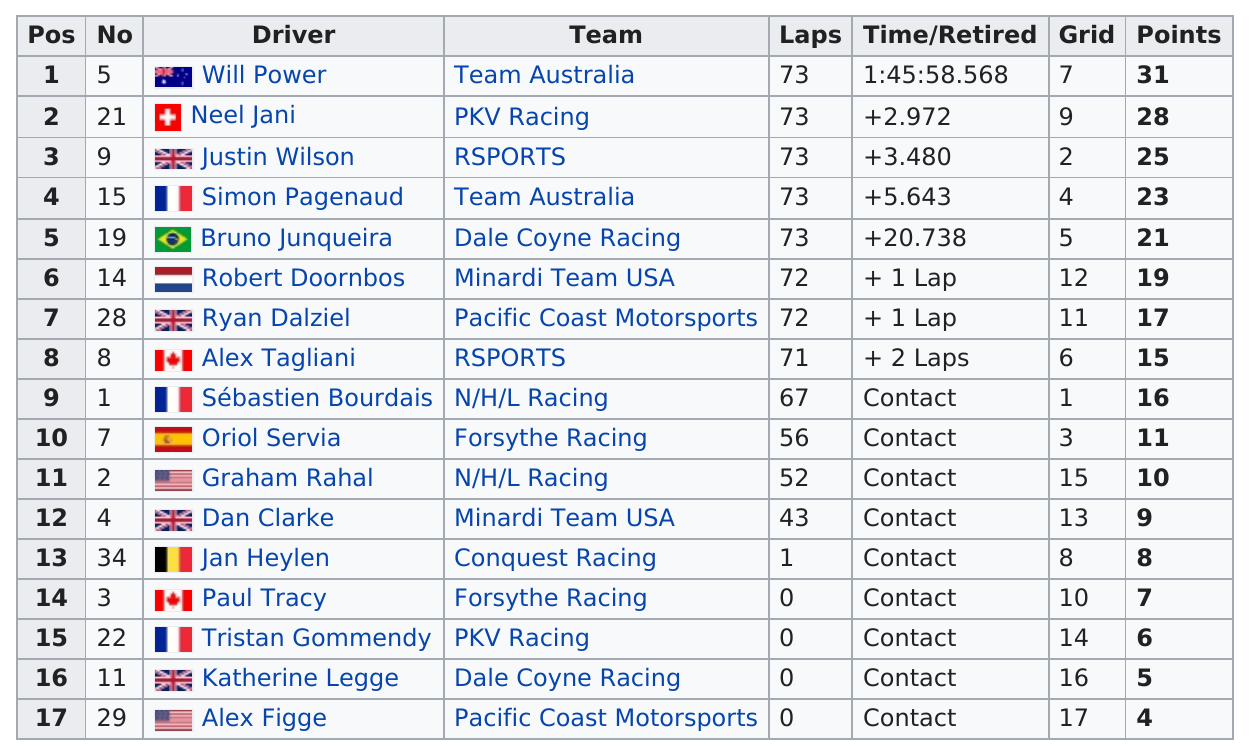Outline some significant characteristics in this image. Out of the total number of drivers listed, 9 had contact information recorded under their time. Out of the total number of drivers who participated in the race, 9 of them drove for more than 60 laps. Five drivers earned at least 20 points or more. Before Simon Pagenaud finished the 2007 Steelback Grand Prix, Justin Wilson, Neel Jani, and Will Power had already completed the race. The 2007 Steelback Grand Prix was attended by nine different teams. 